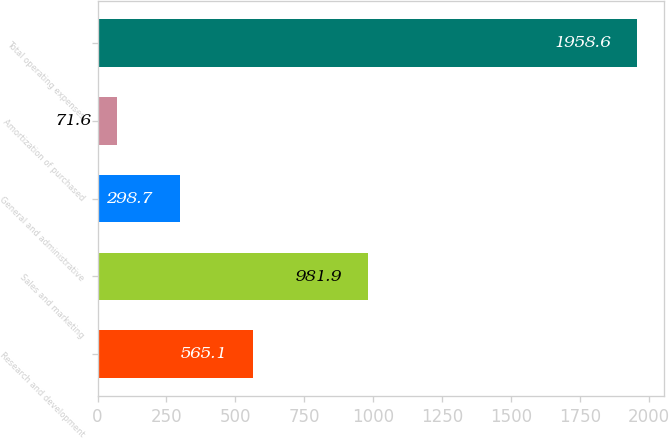<chart> <loc_0><loc_0><loc_500><loc_500><bar_chart><fcel>Research and development<fcel>Sales and marketing<fcel>General and administrative<fcel>Amortization of purchased<fcel>Total operating expenses<nl><fcel>565.1<fcel>981.9<fcel>298.7<fcel>71.6<fcel>1958.6<nl></chart> 